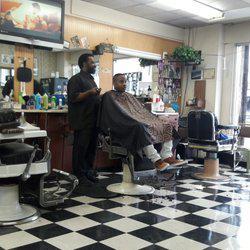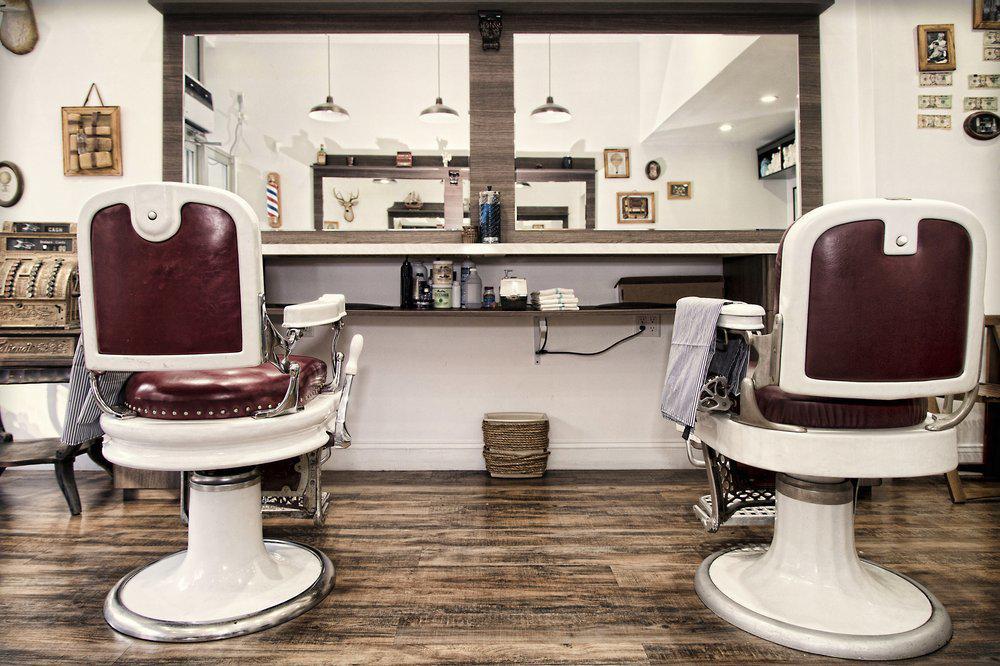The first image is the image on the left, the second image is the image on the right. For the images displayed, is the sentence "A barber is standing behind a client who is sitting." factually correct? Answer yes or no. Yes. 